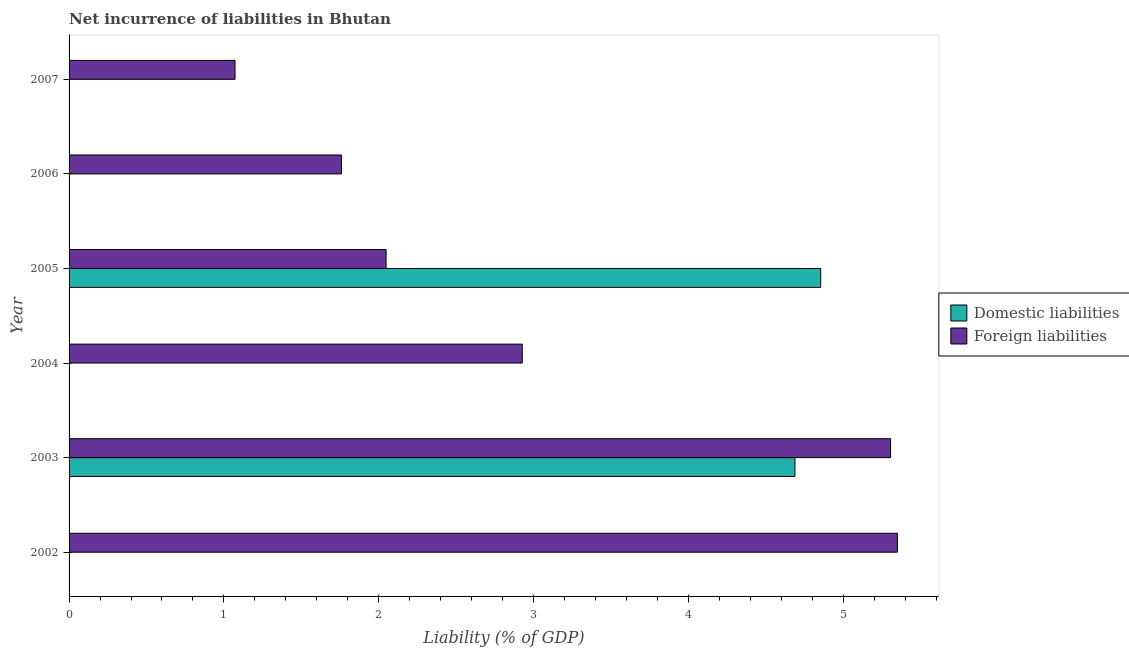How many different coloured bars are there?
Offer a very short reply. 2. Are the number of bars per tick equal to the number of legend labels?
Provide a short and direct response. No. Are the number of bars on each tick of the Y-axis equal?
Give a very brief answer. No. How many bars are there on the 6th tick from the top?
Offer a terse response. 1. How many bars are there on the 3rd tick from the bottom?
Make the answer very short. 1. What is the incurrence of foreign liabilities in 2004?
Your answer should be very brief. 2.93. Across all years, what is the maximum incurrence of foreign liabilities?
Your answer should be compact. 5.35. Across all years, what is the minimum incurrence of foreign liabilities?
Make the answer very short. 1.07. What is the total incurrence of foreign liabilities in the graph?
Give a very brief answer. 18.46. What is the difference between the incurrence of foreign liabilities in 2002 and that in 2003?
Provide a short and direct response. 0.04. What is the difference between the incurrence of foreign liabilities in 2002 and the incurrence of domestic liabilities in 2004?
Offer a terse response. 5.35. What is the average incurrence of domestic liabilities per year?
Your response must be concise. 1.59. In the year 2003, what is the difference between the incurrence of foreign liabilities and incurrence of domestic liabilities?
Your response must be concise. 0.62. What is the difference between the highest and the second highest incurrence of foreign liabilities?
Your response must be concise. 0.04. What is the difference between the highest and the lowest incurrence of domestic liabilities?
Offer a very short reply. 4.85. In how many years, is the incurrence of foreign liabilities greater than the average incurrence of foreign liabilities taken over all years?
Your answer should be compact. 2. How many bars are there?
Give a very brief answer. 8. Are all the bars in the graph horizontal?
Offer a very short reply. Yes. What is the difference between two consecutive major ticks on the X-axis?
Make the answer very short. 1. Are the values on the major ticks of X-axis written in scientific E-notation?
Your answer should be compact. No. Does the graph contain grids?
Provide a short and direct response. No. How are the legend labels stacked?
Your response must be concise. Vertical. What is the title of the graph?
Make the answer very short. Net incurrence of liabilities in Bhutan. Does "Nitrous oxide emissions" appear as one of the legend labels in the graph?
Make the answer very short. No. What is the label or title of the X-axis?
Your answer should be very brief. Liability (% of GDP). What is the label or title of the Y-axis?
Offer a very short reply. Year. What is the Liability (% of GDP) of Foreign liabilities in 2002?
Keep it short and to the point. 5.35. What is the Liability (% of GDP) in Domestic liabilities in 2003?
Provide a short and direct response. 4.69. What is the Liability (% of GDP) in Foreign liabilities in 2003?
Your answer should be compact. 5.31. What is the Liability (% of GDP) in Foreign liabilities in 2004?
Your answer should be compact. 2.93. What is the Liability (% of GDP) of Domestic liabilities in 2005?
Keep it short and to the point. 4.85. What is the Liability (% of GDP) of Foreign liabilities in 2005?
Offer a terse response. 2.05. What is the Liability (% of GDP) of Domestic liabilities in 2006?
Offer a terse response. 0. What is the Liability (% of GDP) of Foreign liabilities in 2006?
Keep it short and to the point. 1.76. What is the Liability (% of GDP) of Domestic liabilities in 2007?
Your answer should be very brief. 0. What is the Liability (% of GDP) of Foreign liabilities in 2007?
Offer a very short reply. 1.07. Across all years, what is the maximum Liability (% of GDP) of Domestic liabilities?
Your answer should be compact. 4.85. Across all years, what is the maximum Liability (% of GDP) of Foreign liabilities?
Your answer should be compact. 5.35. Across all years, what is the minimum Liability (% of GDP) of Domestic liabilities?
Provide a succinct answer. 0. Across all years, what is the minimum Liability (% of GDP) of Foreign liabilities?
Give a very brief answer. 1.07. What is the total Liability (% of GDP) of Domestic liabilities in the graph?
Keep it short and to the point. 9.54. What is the total Liability (% of GDP) of Foreign liabilities in the graph?
Your answer should be compact. 18.46. What is the difference between the Liability (% of GDP) in Foreign liabilities in 2002 and that in 2003?
Provide a succinct answer. 0.04. What is the difference between the Liability (% of GDP) in Foreign liabilities in 2002 and that in 2004?
Provide a succinct answer. 2.42. What is the difference between the Liability (% of GDP) of Foreign liabilities in 2002 and that in 2005?
Make the answer very short. 3.3. What is the difference between the Liability (% of GDP) of Foreign liabilities in 2002 and that in 2006?
Offer a terse response. 3.59. What is the difference between the Liability (% of GDP) in Foreign liabilities in 2002 and that in 2007?
Provide a succinct answer. 4.28. What is the difference between the Liability (% of GDP) of Foreign liabilities in 2003 and that in 2004?
Provide a succinct answer. 2.38. What is the difference between the Liability (% of GDP) in Domestic liabilities in 2003 and that in 2005?
Your answer should be very brief. -0.17. What is the difference between the Liability (% of GDP) in Foreign liabilities in 2003 and that in 2005?
Your answer should be compact. 3.26. What is the difference between the Liability (% of GDP) of Foreign liabilities in 2003 and that in 2006?
Keep it short and to the point. 3.55. What is the difference between the Liability (% of GDP) of Foreign liabilities in 2003 and that in 2007?
Provide a succinct answer. 4.23. What is the difference between the Liability (% of GDP) of Foreign liabilities in 2004 and that in 2005?
Your response must be concise. 0.88. What is the difference between the Liability (% of GDP) of Foreign liabilities in 2004 and that in 2006?
Your answer should be compact. 1.17. What is the difference between the Liability (% of GDP) of Foreign liabilities in 2004 and that in 2007?
Offer a terse response. 1.86. What is the difference between the Liability (% of GDP) in Foreign liabilities in 2005 and that in 2006?
Your answer should be compact. 0.29. What is the difference between the Liability (% of GDP) of Foreign liabilities in 2005 and that in 2007?
Ensure brevity in your answer.  0.98. What is the difference between the Liability (% of GDP) of Foreign liabilities in 2006 and that in 2007?
Ensure brevity in your answer.  0.69. What is the difference between the Liability (% of GDP) of Domestic liabilities in 2003 and the Liability (% of GDP) of Foreign liabilities in 2004?
Keep it short and to the point. 1.76. What is the difference between the Liability (% of GDP) in Domestic liabilities in 2003 and the Liability (% of GDP) in Foreign liabilities in 2005?
Offer a terse response. 2.64. What is the difference between the Liability (% of GDP) in Domestic liabilities in 2003 and the Liability (% of GDP) in Foreign liabilities in 2006?
Your answer should be very brief. 2.93. What is the difference between the Liability (% of GDP) of Domestic liabilities in 2003 and the Liability (% of GDP) of Foreign liabilities in 2007?
Your answer should be compact. 3.62. What is the difference between the Liability (% of GDP) of Domestic liabilities in 2005 and the Liability (% of GDP) of Foreign liabilities in 2006?
Your response must be concise. 3.1. What is the difference between the Liability (% of GDP) of Domestic liabilities in 2005 and the Liability (% of GDP) of Foreign liabilities in 2007?
Your answer should be compact. 3.78. What is the average Liability (% of GDP) in Domestic liabilities per year?
Your response must be concise. 1.59. What is the average Liability (% of GDP) in Foreign liabilities per year?
Ensure brevity in your answer.  3.08. In the year 2003, what is the difference between the Liability (% of GDP) in Domestic liabilities and Liability (% of GDP) in Foreign liabilities?
Offer a terse response. -0.62. In the year 2005, what is the difference between the Liability (% of GDP) of Domestic liabilities and Liability (% of GDP) of Foreign liabilities?
Your response must be concise. 2.81. What is the ratio of the Liability (% of GDP) of Foreign liabilities in 2002 to that in 2003?
Ensure brevity in your answer.  1.01. What is the ratio of the Liability (% of GDP) in Foreign liabilities in 2002 to that in 2004?
Your answer should be compact. 1.83. What is the ratio of the Liability (% of GDP) of Foreign liabilities in 2002 to that in 2005?
Ensure brevity in your answer.  2.61. What is the ratio of the Liability (% of GDP) in Foreign liabilities in 2002 to that in 2006?
Make the answer very short. 3.04. What is the ratio of the Liability (% of GDP) in Foreign liabilities in 2002 to that in 2007?
Your answer should be very brief. 4.99. What is the ratio of the Liability (% of GDP) of Foreign liabilities in 2003 to that in 2004?
Your answer should be very brief. 1.81. What is the ratio of the Liability (% of GDP) of Domestic liabilities in 2003 to that in 2005?
Your answer should be very brief. 0.97. What is the ratio of the Liability (% of GDP) in Foreign liabilities in 2003 to that in 2005?
Make the answer very short. 2.59. What is the ratio of the Liability (% of GDP) of Foreign liabilities in 2003 to that in 2006?
Your answer should be compact. 3.02. What is the ratio of the Liability (% of GDP) in Foreign liabilities in 2003 to that in 2007?
Your answer should be very brief. 4.95. What is the ratio of the Liability (% of GDP) in Foreign liabilities in 2004 to that in 2005?
Make the answer very short. 1.43. What is the ratio of the Liability (% of GDP) of Foreign liabilities in 2004 to that in 2006?
Make the answer very short. 1.66. What is the ratio of the Liability (% of GDP) in Foreign liabilities in 2004 to that in 2007?
Your answer should be compact. 2.73. What is the ratio of the Liability (% of GDP) in Foreign liabilities in 2005 to that in 2006?
Offer a terse response. 1.16. What is the ratio of the Liability (% of GDP) of Foreign liabilities in 2005 to that in 2007?
Your answer should be compact. 1.91. What is the ratio of the Liability (% of GDP) in Foreign liabilities in 2006 to that in 2007?
Your answer should be compact. 1.64. What is the difference between the highest and the second highest Liability (% of GDP) of Foreign liabilities?
Offer a very short reply. 0.04. What is the difference between the highest and the lowest Liability (% of GDP) in Domestic liabilities?
Provide a succinct answer. 4.85. What is the difference between the highest and the lowest Liability (% of GDP) in Foreign liabilities?
Make the answer very short. 4.28. 